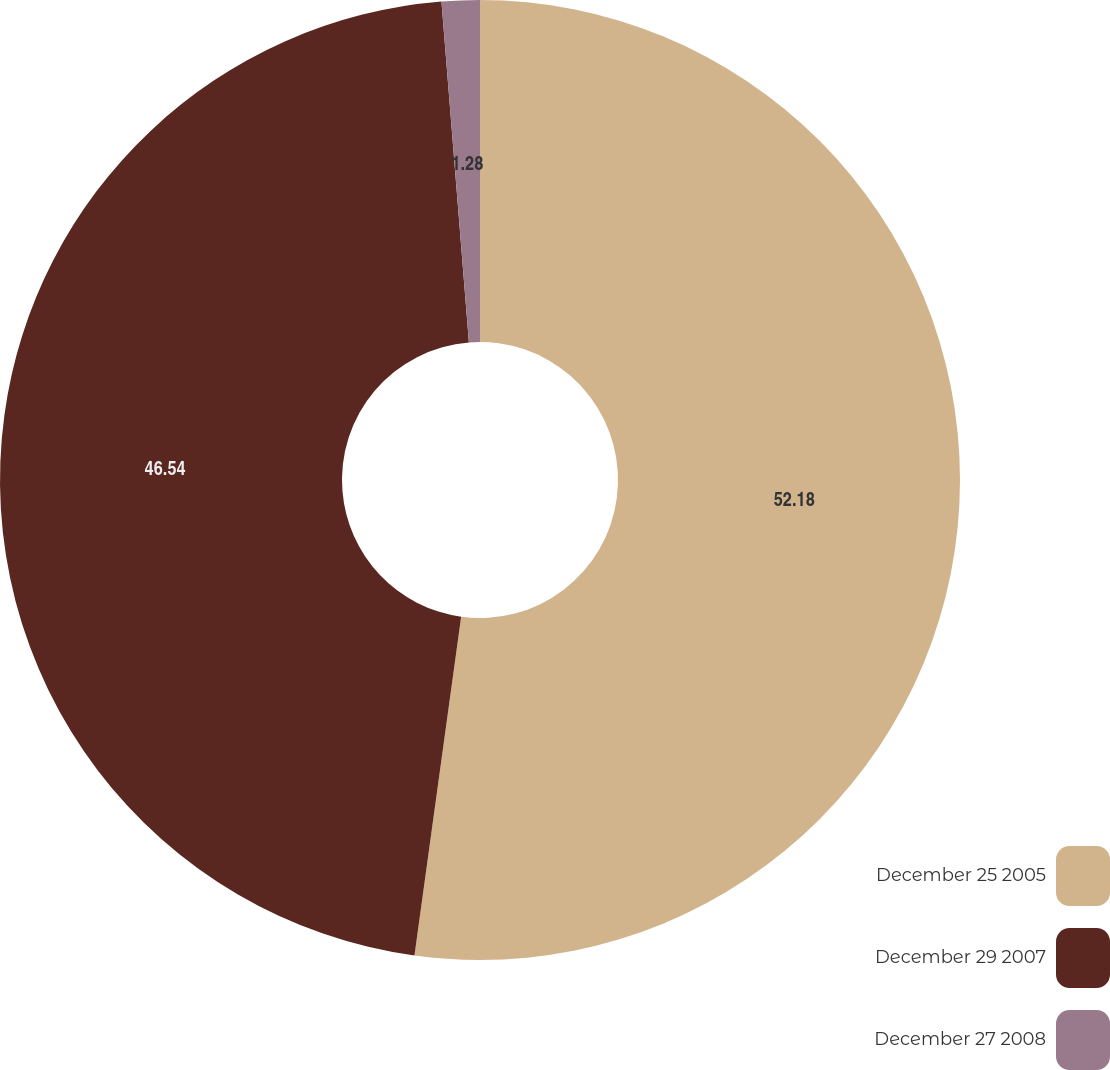Convert chart. <chart><loc_0><loc_0><loc_500><loc_500><pie_chart><fcel>December 25 2005<fcel>December 29 2007<fcel>December 27 2008<nl><fcel>52.18%<fcel>46.54%<fcel>1.28%<nl></chart> 